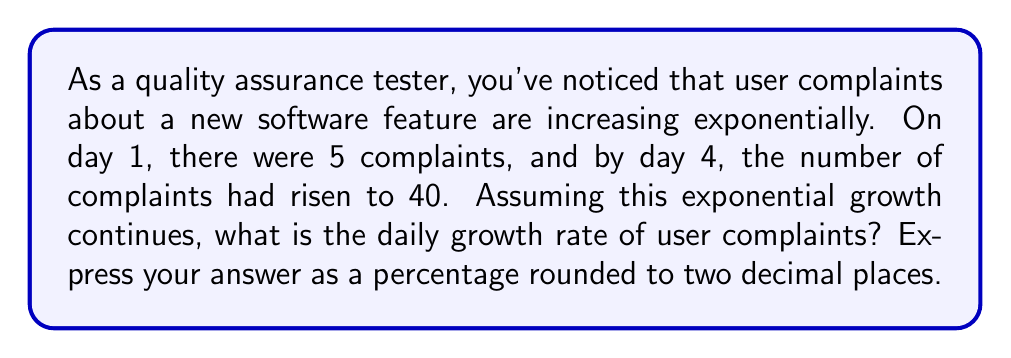Provide a solution to this math problem. Let's approach this step-by-step using the exponential growth formula:

1) The exponential growth formula is:
   $A = P(1 + r)^t$
   where A is the final amount, P is the initial amount, r is the daily growth rate, and t is the time in days.

2) We know:
   P = 5 (initial complaints on day 1)
   A = 40 (complaints on day 4)
   t = 3 (from day 1 to day 4 is 3 days)

3) Plugging these into our formula:
   $40 = 5(1 + r)^3$

4) Divide both sides by 5:
   $8 = (1 + r)^3$

5) Take the cube root of both sides:
   $\sqrt[3]{8} = 1 + r$

6) Simplify:
   $2 = 1 + r$

7) Subtract 1 from both sides:
   $1 = r$

8) Convert to a percentage:
   $r = 1 = 100\%$

Therefore, the daily growth rate is 100%.
Answer: 100.00% 